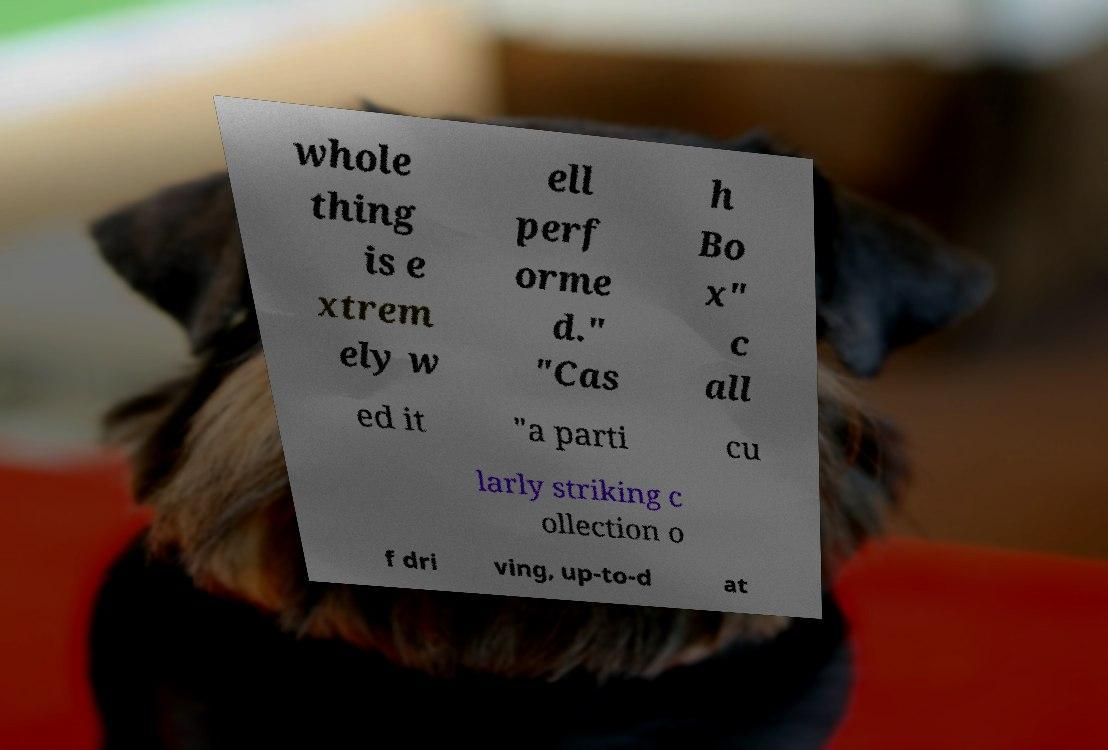Can you read and provide the text displayed in the image?This photo seems to have some interesting text. Can you extract and type it out for me? whole thing is e xtrem ely w ell perf orme d." "Cas h Bo x" c all ed it "a parti cu larly striking c ollection o f dri ving, up-to-d at 